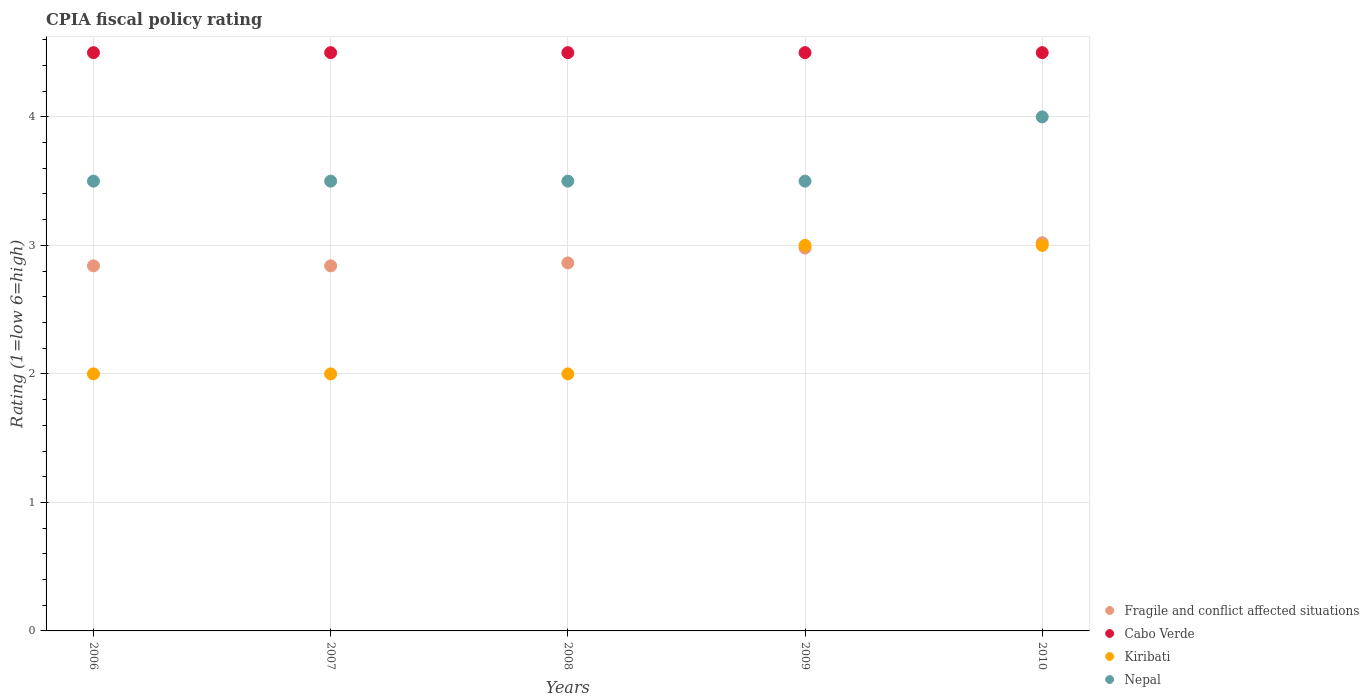Is the number of dotlines equal to the number of legend labels?
Offer a very short reply. Yes. What is the CPIA rating in Fragile and conflict affected situations in 2008?
Your answer should be compact. 2.86. Across all years, what is the maximum CPIA rating in Nepal?
Provide a succinct answer. 4. Across all years, what is the minimum CPIA rating in Kiribati?
Your response must be concise. 2. In which year was the CPIA rating in Nepal minimum?
Your answer should be compact. 2006. What is the total CPIA rating in Fragile and conflict affected situations in the graph?
Ensure brevity in your answer.  14.55. What is the difference between the CPIA rating in Nepal in 2009 and that in 2010?
Offer a terse response. -0.5. What is the difference between the CPIA rating in Kiribati in 2010 and the CPIA rating in Fragile and conflict affected situations in 2007?
Ensure brevity in your answer.  0.16. In the year 2010, what is the difference between the CPIA rating in Cabo Verde and CPIA rating in Kiribati?
Keep it short and to the point. 1.5. Is the difference between the CPIA rating in Cabo Verde in 2008 and 2010 greater than the difference between the CPIA rating in Kiribati in 2008 and 2010?
Provide a succinct answer. Yes. What is the difference between the highest and the second highest CPIA rating in Nepal?
Provide a succinct answer. 0.5. What is the difference between the highest and the lowest CPIA rating in Cabo Verde?
Your response must be concise. 0. Is the sum of the CPIA rating in Nepal in 2008 and 2009 greater than the maximum CPIA rating in Fragile and conflict affected situations across all years?
Make the answer very short. Yes. Is it the case that in every year, the sum of the CPIA rating in Cabo Verde and CPIA rating in Nepal  is greater than the CPIA rating in Kiribati?
Your answer should be compact. Yes. Is the CPIA rating in Nepal strictly greater than the CPIA rating in Fragile and conflict affected situations over the years?
Provide a short and direct response. Yes. How many years are there in the graph?
Your response must be concise. 5. Are the values on the major ticks of Y-axis written in scientific E-notation?
Your response must be concise. No. Does the graph contain any zero values?
Provide a succinct answer. No. Does the graph contain grids?
Make the answer very short. Yes. What is the title of the graph?
Keep it short and to the point. CPIA fiscal policy rating. What is the Rating (1=low 6=high) in Fragile and conflict affected situations in 2006?
Offer a terse response. 2.84. What is the Rating (1=low 6=high) of Kiribati in 2006?
Provide a short and direct response. 2. What is the Rating (1=low 6=high) of Nepal in 2006?
Your response must be concise. 3.5. What is the Rating (1=low 6=high) in Fragile and conflict affected situations in 2007?
Keep it short and to the point. 2.84. What is the Rating (1=low 6=high) in Cabo Verde in 2007?
Make the answer very short. 4.5. What is the Rating (1=low 6=high) in Kiribati in 2007?
Your response must be concise. 2. What is the Rating (1=low 6=high) in Nepal in 2007?
Ensure brevity in your answer.  3.5. What is the Rating (1=low 6=high) in Fragile and conflict affected situations in 2008?
Provide a short and direct response. 2.86. What is the Rating (1=low 6=high) of Fragile and conflict affected situations in 2009?
Provide a succinct answer. 2.98. What is the Rating (1=low 6=high) of Cabo Verde in 2009?
Offer a very short reply. 4.5. What is the Rating (1=low 6=high) of Kiribati in 2009?
Your response must be concise. 3. What is the Rating (1=low 6=high) of Nepal in 2009?
Ensure brevity in your answer.  3.5. What is the Rating (1=low 6=high) of Fragile and conflict affected situations in 2010?
Provide a short and direct response. 3.02. What is the Rating (1=low 6=high) of Kiribati in 2010?
Keep it short and to the point. 3. Across all years, what is the maximum Rating (1=low 6=high) of Fragile and conflict affected situations?
Make the answer very short. 3.02. Across all years, what is the maximum Rating (1=low 6=high) of Kiribati?
Provide a succinct answer. 3. Across all years, what is the minimum Rating (1=low 6=high) of Fragile and conflict affected situations?
Offer a very short reply. 2.84. Across all years, what is the minimum Rating (1=low 6=high) in Kiribati?
Make the answer very short. 2. What is the total Rating (1=low 6=high) in Fragile and conflict affected situations in the graph?
Provide a succinct answer. 14.55. What is the total Rating (1=low 6=high) of Cabo Verde in the graph?
Give a very brief answer. 22.5. What is the total Rating (1=low 6=high) in Nepal in the graph?
Keep it short and to the point. 18. What is the difference between the Rating (1=low 6=high) in Cabo Verde in 2006 and that in 2007?
Your answer should be compact. 0. What is the difference between the Rating (1=low 6=high) of Kiribati in 2006 and that in 2007?
Your answer should be very brief. 0. What is the difference between the Rating (1=low 6=high) in Fragile and conflict affected situations in 2006 and that in 2008?
Ensure brevity in your answer.  -0.02. What is the difference between the Rating (1=low 6=high) in Nepal in 2006 and that in 2008?
Offer a terse response. 0. What is the difference between the Rating (1=low 6=high) of Fragile and conflict affected situations in 2006 and that in 2009?
Give a very brief answer. -0.14. What is the difference between the Rating (1=low 6=high) of Nepal in 2006 and that in 2009?
Offer a terse response. 0. What is the difference between the Rating (1=low 6=high) in Fragile and conflict affected situations in 2006 and that in 2010?
Your answer should be compact. -0.18. What is the difference between the Rating (1=low 6=high) in Kiribati in 2006 and that in 2010?
Provide a short and direct response. -1. What is the difference between the Rating (1=low 6=high) in Nepal in 2006 and that in 2010?
Make the answer very short. -0.5. What is the difference between the Rating (1=low 6=high) of Fragile and conflict affected situations in 2007 and that in 2008?
Make the answer very short. -0.02. What is the difference between the Rating (1=low 6=high) of Kiribati in 2007 and that in 2008?
Offer a very short reply. 0. What is the difference between the Rating (1=low 6=high) in Nepal in 2007 and that in 2008?
Your answer should be very brief. 0. What is the difference between the Rating (1=low 6=high) of Fragile and conflict affected situations in 2007 and that in 2009?
Your answer should be compact. -0.14. What is the difference between the Rating (1=low 6=high) of Cabo Verde in 2007 and that in 2009?
Offer a terse response. 0. What is the difference between the Rating (1=low 6=high) in Fragile and conflict affected situations in 2007 and that in 2010?
Offer a terse response. -0.18. What is the difference between the Rating (1=low 6=high) of Kiribati in 2007 and that in 2010?
Your answer should be compact. -1. What is the difference between the Rating (1=low 6=high) of Nepal in 2007 and that in 2010?
Your answer should be compact. -0.5. What is the difference between the Rating (1=low 6=high) of Fragile and conflict affected situations in 2008 and that in 2009?
Make the answer very short. -0.12. What is the difference between the Rating (1=low 6=high) of Cabo Verde in 2008 and that in 2009?
Provide a short and direct response. 0. What is the difference between the Rating (1=low 6=high) of Nepal in 2008 and that in 2009?
Your answer should be compact. 0. What is the difference between the Rating (1=low 6=high) in Fragile and conflict affected situations in 2008 and that in 2010?
Provide a succinct answer. -0.16. What is the difference between the Rating (1=low 6=high) of Cabo Verde in 2008 and that in 2010?
Make the answer very short. 0. What is the difference between the Rating (1=low 6=high) in Fragile and conflict affected situations in 2009 and that in 2010?
Ensure brevity in your answer.  -0.04. What is the difference between the Rating (1=low 6=high) in Cabo Verde in 2009 and that in 2010?
Your answer should be compact. 0. What is the difference between the Rating (1=low 6=high) of Kiribati in 2009 and that in 2010?
Offer a very short reply. 0. What is the difference between the Rating (1=low 6=high) of Nepal in 2009 and that in 2010?
Make the answer very short. -0.5. What is the difference between the Rating (1=low 6=high) of Fragile and conflict affected situations in 2006 and the Rating (1=low 6=high) of Cabo Verde in 2007?
Offer a very short reply. -1.66. What is the difference between the Rating (1=low 6=high) in Fragile and conflict affected situations in 2006 and the Rating (1=low 6=high) in Kiribati in 2007?
Make the answer very short. 0.84. What is the difference between the Rating (1=low 6=high) of Fragile and conflict affected situations in 2006 and the Rating (1=low 6=high) of Nepal in 2007?
Make the answer very short. -0.66. What is the difference between the Rating (1=low 6=high) of Cabo Verde in 2006 and the Rating (1=low 6=high) of Kiribati in 2007?
Offer a very short reply. 2.5. What is the difference between the Rating (1=low 6=high) in Cabo Verde in 2006 and the Rating (1=low 6=high) in Nepal in 2007?
Your answer should be compact. 1. What is the difference between the Rating (1=low 6=high) of Kiribati in 2006 and the Rating (1=low 6=high) of Nepal in 2007?
Give a very brief answer. -1.5. What is the difference between the Rating (1=low 6=high) in Fragile and conflict affected situations in 2006 and the Rating (1=low 6=high) in Cabo Verde in 2008?
Keep it short and to the point. -1.66. What is the difference between the Rating (1=low 6=high) in Fragile and conflict affected situations in 2006 and the Rating (1=low 6=high) in Kiribati in 2008?
Provide a short and direct response. 0.84. What is the difference between the Rating (1=low 6=high) of Fragile and conflict affected situations in 2006 and the Rating (1=low 6=high) of Nepal in 2008?
Provide a succinct answer. -0.66. What is the difference between the Rating (1=low 6=high) of Cabo Verde in 2006 and the Rating (1=low 6=high) of Kiribati in 2008?
Offer a very short reply. 2.5. What is the difference between the Rating (1=low 6=high) of Kiribati in 2006 and the Rating (1=low 6=high) of Nepal in 2008?
Provide a short and direct response. -1.5. What is the difference between the Rating (1=low 6=high) in Fragile and conflict affected situations in 2006 and the Rating (1=low 6=high) in Cabo Verde in 2009?
Give a very brief answer. -1.66. What is the difference between the Rating (1=low 6=high) in Fragile and conflict affected situations in 2006 and the Rating (1=low 6=high) in Kiribati in 2009?
Provide a short and direct response. -0.16. What is the difference between the Rating (1=low 6=high) in Fragile and conflict affected situations in 2006 and the Rating (1=low 6=high) in Nepal in 2009?
Your answer should be very brief. -0.66. What is the difference between the Rating (1=low 6=high) of Cabo Verde in 2006 and the Rating (1=low 6=high) of Nepal in 2009?
Ensure brevity in your answer.  1. What is the difference between the Rating (1=low 6=high) of Kiribati in 2006 and the Rating (1=low 6=high) of Nepal in 2009?
Offer a terse response. -1.5. What is the difference between the Rating (1=low 6=high) of Fragile and conflict affected situations in 2006 and the Rating (1=low 6=high) of Cabo Verde in 2010?
Offer a very short reply. -1.66. What is the difference between the Rating (1=low 6=high) in Fragile and conflict affected situations in 2006 and the Rating (1=low 6=high) in Kiribati in 2010?
Offer a terse response. -0.16. What is the difference between the Rating (1=low 6=high) in Fragile and conflict affected situations in 2006 and the Rating (1=low 6=high) in Nepal in 2010?
Make the answer very short. -1.16. What is the difference between the Rating (1=low 6=high) in Cabo Verde in 2006 and the Rating (1=low 6=high) in Kiribati in 2010?
Your response must be concise. 1.5. What is the difference between the Rating (1=low 6=high) of Cabo Verde in 2006 and the Rating (1=low 6=high) of Nepal in 2010?
Ensure brevity in your answer.  0.5. What is the difference between the Rating (1=low 6=high) of Fragile and conflict affected situations in 2007 and the Rating (1=low 6=high) of Cabo Verde in 2008?
Your answer should be very brief. -1.66. What is the difference between the Rating (1=low 6=high) in Fragile and conflict affected situations in 2007 and the Rating (1=low 6=high) in Kiribati in 2008?
Offer a very short reply. 0.84. What is the difference between the Rating (1=low 6=high) in Fragile and conflict affected situations in 2007 and the Rating (1=low 6=high) in Nepal in 2008?
Offer a very short reply. -0.66. What is the difference between the Rating (1=low 6=high) in Cabo Verde in 2007 and the Rating (1=low 6=high) in Nepal in 2008?
Your response must be concise. 1. What is the difference between the Rating (1=low 6=high) in Fragile and conflict affected situations in 2007 and the Rating (1=low 6=high) in Cabo Verde in 2009?
Offer a very short reply. -1.66. What is the difference between the Rating (1=low 6=high) of Fragile and conflict affected situations in 2007 and the Rating (1=low 6=high) of Kiribati in 2009?
Your response must be concise. -0.16. What is the difference between the Rating (1=low 6=high) of Fragile and conflict affected situations in 2007 and the Rating (1=low 6=high) of Nepal in 2009?
Keep it short and to the point. -0.66. What is the difference between the Rating (1=low 6=high) in Kiribati in 2007 and the Rating (1=low 6=high) in Nepal in 2009?
Offer a terse response. -1.5. What is the difference between the Rating (1=low 6=high) of Fragile and conflict affected situations in 2007 and the Rating (1=low 6=high) of Cabo Verde in 2010?
Provide a short and direct response. -1.66. What is the difference between the Rating (1=low 6=high) of Fragile and conflict affected situations in 2007 and the Rating (1=low 6=high) of Kiribati in 2010?
Offer a terse response. -0.16. What is the difference between the Rating (1=low 6=high) in Fragile and conflict affected situations in 2007 and the Rating (1=low 6=high) in Nepal in 2010?
Provide a short and direct response. -1.16. What is the difference between the Rating (1=low 6=high) in Cabo Verde in 2007 and the Rating (1=low 6=high) in Nepal in 2010?
Make the answer very short. 0.5. What is the difference between the Rating (1=low 6=high) in Fragile and conflict affected situations in 2008 and the Rating (1=low 6=high) in Cabo Verde in 2009?
Your answer should be compact. -1.64. What is the difference between the Rating (1=low 6=high) in Fragile and conflict affected situations in 2008 and the Rating (1=low 6=high) in Kiribati in 2009?
Your response must be concise. -0.14. What is the difference between the Rating (1=low 6=high) in Fragile and conflict affected situations in 2008 and the Rating (1=low 6=high) in Nepal in 2009?
Offer a very short reply. -0.64. What is the difference between the Rating (1=low 6=high) in Cabo Verde in 2008 and the Rating (1=low 6=high) in Kiribati in 2009?
Make the answer very short. 1.5. What is the difference between the Rating (1=low 6=high) of Kiribati in 2008 and the Rating (1=low 6=high) of Nepal in 2009?
Ensure brevity in your answer.  -1.5. What is the difference between the Rating (1=low 6=high) in Fragile and conflict affected situations in 2008 and the Rating (1=low 6=high) in Cabo Verde in 2010?
Your response must be concise. -1.64. What is the difference between the Rating (1=low 6=high) in Fragile and conflict affected situations in 2008 and the Rating (1=low 6=high) in Kiribati in 2010?
Offer a very short reply. -0.14. What is the difference between the Rating (1=low 6=high) of Fragile and conflict affected situations in 2008 and the Rating (1=low 6=high) of Nepal in 2010?
Provide a short and direct response. -1.14. What is the difference between the Rating (1=low 6=high) of Fragile and conflict affected situations in 2009 and the Rating (1=low 6=high) of Cabo Verde in 2010?
Offer a terse response. -1.52. What is the difference between the Rating (1=low 6=high) of Fragile and conflict affected situations in 2009 and the Rating (1=low 6=high) of Kiribati in 2010?
Your answer should be compact. -0.02. What is the difference between the Rating (1=low 6=high) in Fragile and conflict affected situations in 2009 and the Rating (1=low 6=high) in Nepal in 2010?
Make the answer very short. -1.02. What is the average Rating (1=low 6=high) in Fragile and conflict affected situations per year?
Keep it short and to the point. 2.91. What is the average Rating (1=low 6=high) of Kiribati per year?
Offer a very short reply. 2.4. In the year 2006, what is the difference between the Rating (1=low 6=high) of Fragile and conflict affected situations and Rating (1=low 6=high) of Cabo Verde?
Ensure brevity in your answer.  -1.66. In the year 2006, what is the difference between the Rating (1=low 6=high) in Fragile and conflict affected situations and Rating (1=low 6=high) in Kiribati?
Your answer should be compact. 0.84. In the year 2006, what is the difference between the Rating (1=low 6=high) of Fragile and conflict affected situations and Rating (1=low 6=high) of Nepal?
Your answer should be very brief. -0.66. In the year 2006, what is the difference between the Rating (1=low 6=high) in Cabo Verde and Rating (1=low 6=high) in Kiribati?
Give a very brief answer. 2.5. In the year 2006, what is the difference between the Rating (1=low 6=high) in Cabo Verde and Rating (1=low 6=high) in Nepal?
Ensure brevity in your answer.  1. In the year 2007, what is the difference between the Rating (1=low 6=high) of Fragile and conflict affected situations and Rating (1=low 6=high) of Cabo Verde?
Offer a very short reply. -1.66. In the year 2007, what is the difference between the Rating (1=low 6=high) of Fragile and conflict affected situations and Rating (1=low 6=high) of Kiribati?
Keep it short and to the point. 0.84. In the year 2007, what is the difference between the Rating (1=low 6=high) in Fragile and conflict affected situations and Rating (1=low 6=high) in Nepal?
Offer a very short reply. -0.66. In the year 2007, what is the difference between the Rating (1=low 6=high) of Cabo Verde and Rating (1=low 6=high) of Nepal?
Offer a very short reply. 1. In the year 2007, what is the difference between the Rating (1=low 6=high) in Kiribati and Rating (1=low 6=high) in Nepal?
Give a very brief answer. -1.5. In the year 2008, what is the difference between the Rating (1=low 6=high) in Fragile and conflict affected situations and Rating (1=low 6=high) in Cabo Verde?
Provide a succinct answer. -1.64. In the year 2008, what is the difference between the Rating (1=low 6=high) in Fragile and conflict affected situations and Rating (1=low 6=high) in Kiribati?
Offer a very short reply. 0.86. In the year 2008, what is the difference between the Rating (1=low 6=high) of Fragile and conflict affected situations and Rating (1=low 6=high) of Nepal?
Your response must be concise. -0.64. In the year 2008, what is the difference between the Rating (1=low 6=high) of Cabo Verde and Rating (1=low 6=high) of Nepal?
Offer a very short reply. 1. In the year 2009, what is the difference between the Rating (1=low 6=high) of Fragile and conflict affected situations and Rating (1=low 6=high) of Cabo Verde?
Offer a very short reply. -1.52. In the year 2009, what is the difference between the Rating (1=low 6=high) in Fragile and conflict affected situations and Rating (1=low 6=high) in Kiribati?
Give a very brief answer. -0.02. In the year 2009, what is the difference between the Rating (1=low 6=high) in Fragile and conflict affected situations and Rating (1=low 6=high) in Nepal?
Provide a succinct answer. -0.52. In the year 2009, what is the difference between the Rating (1=low 6=high) of Kiribati and Rating (1=low 6=high) of Nepal?
Ensure brevity in your answer.  -0.5. In the year 2010, what is the difference between the Rating (1=low 6=high) in Fragile and conflict affected situations and Rating (1=low 6=high) in Cabo Verde?
Keep it short and to the point. -1.48. In the year 2010, what is the difference between the Rating (1=low 6=high) in Fragile and conflict affected situations and Rating (1=low 6=high) in Kiribati?
Ensure brevity in your answer.  0.02. In the year 2010, what is the difference between the Rating (1=low 6=high) in Fragile and conflict affected situations and Rating (1=low 6=high) in Nepal?
Offer a terse response. -0.98. In the year 2010, what is the difference between the Rating (1=low 6=high) of Kiribati and Rating (1=low 6=high) of Nepal?
Provide a succinct answer. -1. What is the ratio of the Rating (1=low 6=high) of Fragile and conflict affected situations in 2006 to that in 2007?
Offer a terse response. 1. What is the ratio of the Rating (1=low 6=high) in Fragile and conflict affected situations in 2006 to that in 2008?
Offer a very short reply. 0.99. What is the ratio of the Rating (1=low 6=high) of Kiribati in 2006 to that in 2008?
Your response must be concise. 1. What is the ratio of the Rating (1=low 6=high) in Nepal in 2006 to that in 2008?
Keep it short and to the point. 1. What is the ratio of the Rating (1=low 6=high) of Fragile and conflict affected situations in 2006 to that in 2009?
Your answer should be very brief. 0.95. What is the ratio of the Rating (1=low 6=high) in Cabo Verde in 2006 to that in 2009?
Offer a terse response. 1. What is the ratio of the Rating (1=low 6=high) in Kiribati in 2006 to that in 2009?
Make the answer very short. 0.67. What is the ratio of the Rating (1=low 6=high) of Nepal in 2006 to that in 2009?
Keep it short and to the point. 1. What is the ratio of the Rating (1=low 6=high) in Fragile and conflict affected situations in 2006 to that in 2010?
Give a very brief answer. 0.94. What is the ratio of the Rating (1=low 6=high) in Cabo Verde in 2006 to that in 2010?
Give a very brief answer. 1. What is the ratio of the Rating (1=low 6=high) in Fragile and conflict affected situations in 2007 to that in 2008?
Offer a terse response. 0.99. What is the ratio of the Rating (1=low 6=high) in Kiribati in 2007 to that in 2008?
Your response must be concise. 1. What is the ratio of the Rating (1=low 6=high) of Nepal in 2007 to that in 2008?
Your response must be concise. 1. What is the ratio of the Rating (1=low 6=high) in Fragile and conflict affected situations in 2007 to that in 2009?
Offer a terse response. 0.95. What is the ratio of the Rating (1=low 6=high) in Cabo Verde in 2007 to that in 2009?
Offer a very short reply. 1. What is the ratio of the Rating (1=low 6=high) of Kiribati in 2007 to that in 2009?
Ensure brevity in your answer.  0.67. What is the ratio of the Rating (1=low 6=high) of Fragile and conflict affected situations in 2007 to that in 2010?
Provide a short and direct response. 0.94. What is the ratio of the Rating (1=low 6=high) in Kiribati in 2007 to that in 2010?
Give a very brief answer. 0.67. What is the ratio of the Rating (1=low 6=high) in Fragile and conflict affected situations in 2008 to that in 2009?
Offer a very short reply. 0.96. What is the ratio of the Rating (1=low 6=high) of Nepal in 2008 to that in 2009?
Make the answer very short. 1. What is the ratio of the Rating (1=low 6=high) in Fragile and conflict affected situations in 2008 to that in 2010?
Ensure brevity in your answer.  0.95. What is the ratio of the Rating (1=low 6=high) of Cabo Verde in 2008 to that in 2010?
Your response must be concise. 1. What is the ratio of the Rating (1=low 6=high) of Nepal in 2008 to that in 2010?
Make the answer very short. 0.88. What is the ratio of the Rating (1=low 6=high) of Fragile and conflict affected situations in 2009 to that in 2010?
Offer a terse response. 0.99. What is the ratio of the Rating (1=low 6=high) of Nepal in 2009 to that in 2010?
Your response must be concise. 0.88. What is the difference between the highest and the second highest Rating (1=low 6=high) in Fragile and conflict affected situations?
Your answer should be very brief. 0.04. What is the difference between the highest and the second highest Rating (1=low 6=high) in Kiribati?
Offer a very short reply. 0. What is the difference between the highest and the lowest Rating (1=low 6=high) in Fragile and conflict affected situations?
Your response must be concise. 0.18. 